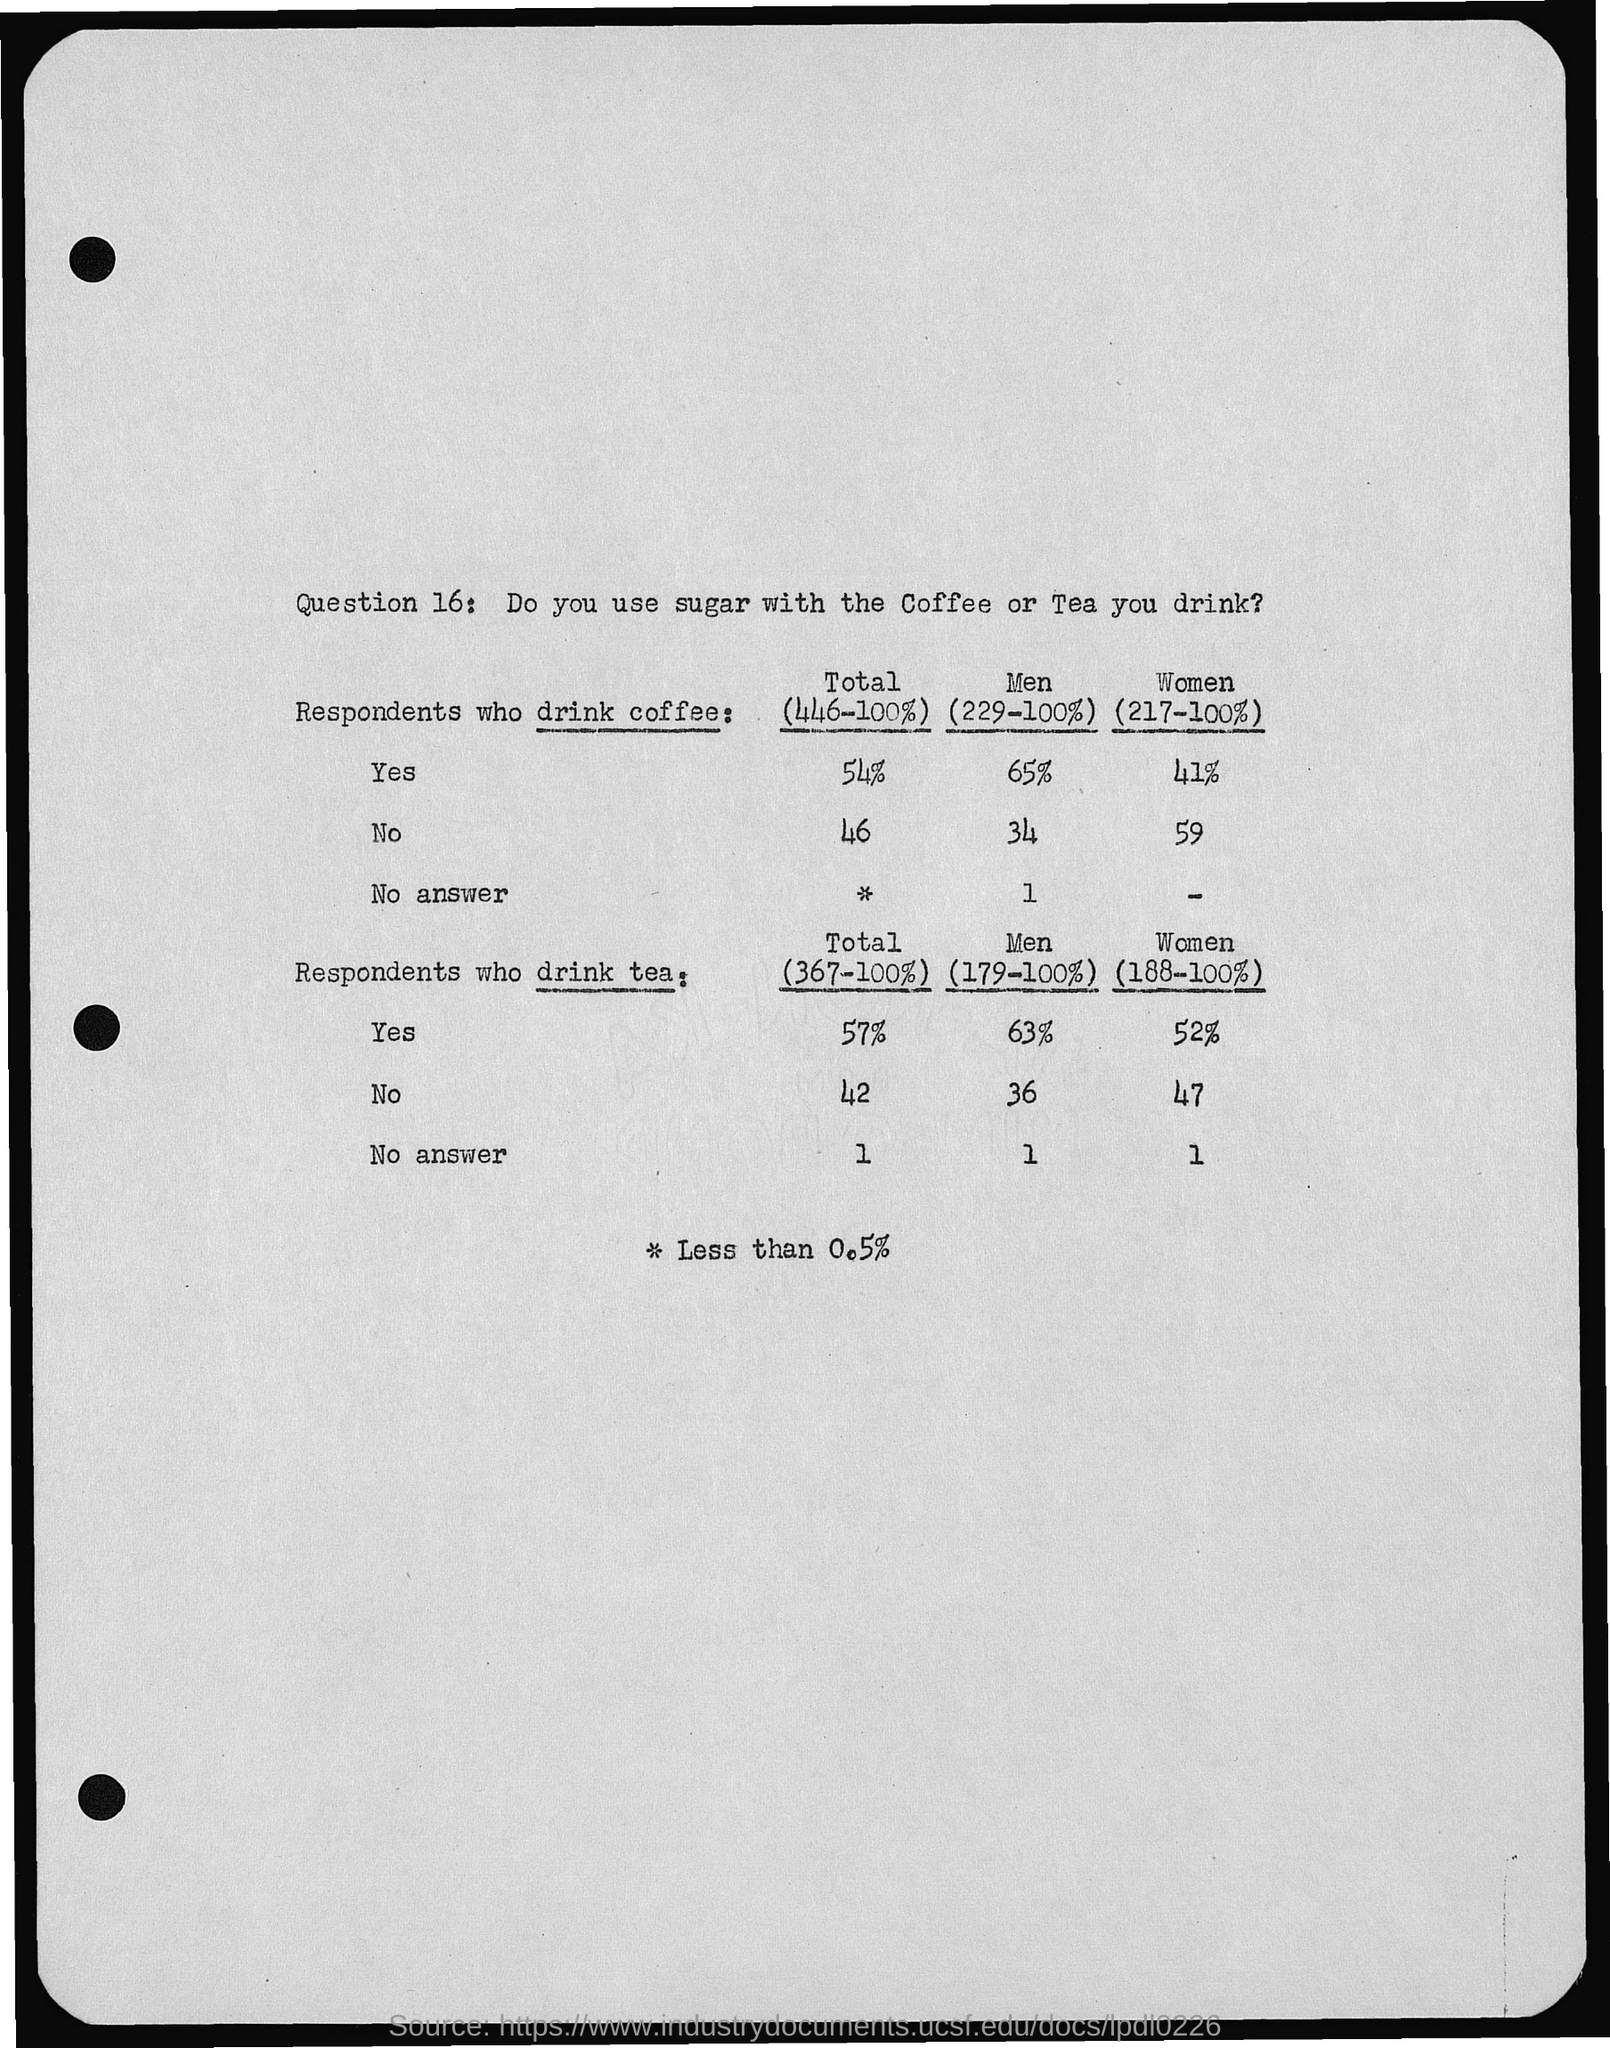What is the Question No.?
Give a very brief answer. Question 16. What is Question 16?
Provide a short and direct response. Do you use sugar with the Coffee or Tea you drink?. What is the percentage of men who drinks coffee?
Make the answer very short. 65%. What is the percentage of women who drinks coffee?
Provide a succinct answer. 41%. What is the percentage of men who doesn't drinks coffee?
Ensure brevity in your answer.  34. What is the percentage of women who drinks tea?
Your response must be concise. 52%. 